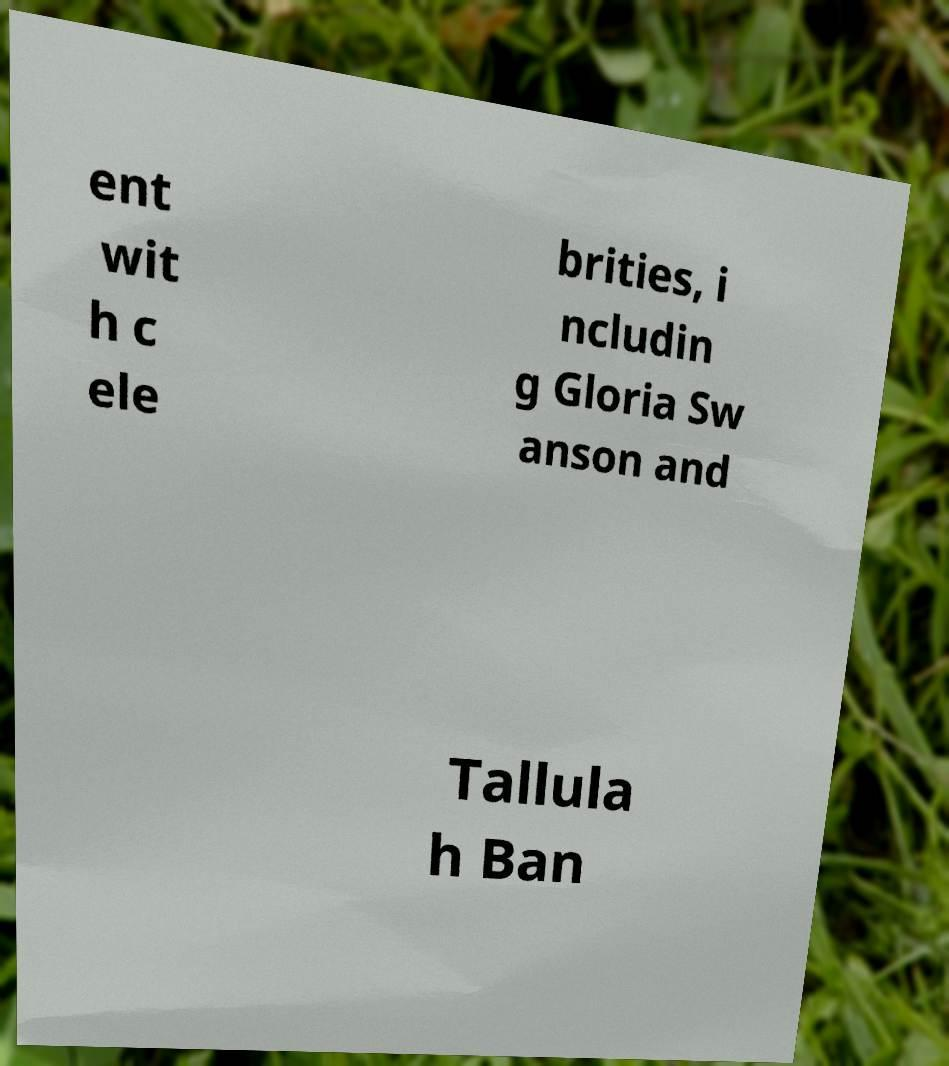Please identify and transcribe the text found in this image. ent wit h c ele brities, i ncludin g Gloria Sw anson and Tallula h Ban 